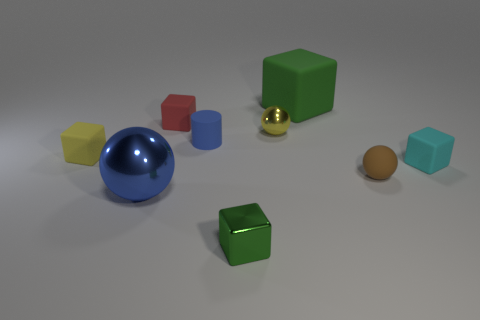Subtract all red cubes. How many cubes are left? 4 Subtract all cyan matte blocks. How many blocks are left? 4 Subtract all brown blocks. Subtract all gray spheres. How many blocks are left? 5 Add 1 yellow cylinders. How many objects exist? 10 Subtract all cubes. How many objects are left? 4 Subtract all small purple metallic cubes. Subtract all matte spheres. How many objects are left? 8 Add 2 red rubber objects. How many red rubber objects are left? 3 Add 2 big matte blocks. How many big matte blocks exist? 3 Subtract 0 brown blocks. How many objects are left? 9 